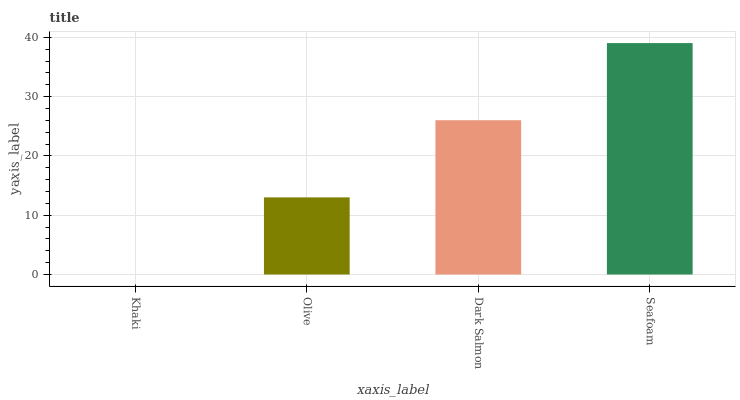Is Khaki the minimum?
Answer yes or no. Yes. Is Seafoam the maximum?
Answer yes or no. Yes. Is Olive the minimum?
Answer yes or no. No. Is Olive the maximum?
Answer yes or no. No. Is Olive greater than Khaki?
Answer yes or no. Yes. Is Khaki less than Olive?
Answer yes or no. Yes. Is Khaki greater than Olive?
Answer yes or no. No. Is Olive less than Khaki?
Answer yes or no. No. Is Dark Salmon the high median?
Answer yes or no. Yes. Is Olive the low median?
Answer yes or no. Yes. Is Olive the high median?
Answer yes or no. No. Is Seafoam the low median?
Answer yes or no. No. 